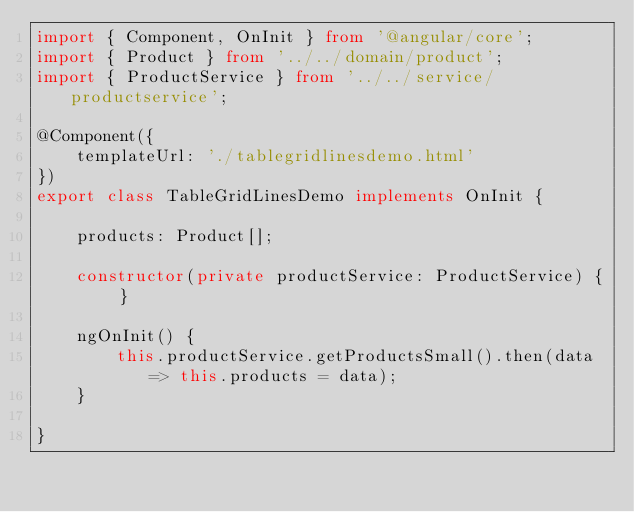Convert code to text. <code><loc_0><loc_0><loc_500><loc_500><_TypeScript_>import { Component, OnInit } from '@angular/core';
import { Product } from '../../domain/product';
import { ProductService } from '../../service/productservice';

@Component({
    templateUrl: './tablegridlinesdemo.html'
})
export class TableGridLinesDemo implements OnInit {

    products: Product[];

    constructor(private productService: ProductService) { }

    ngOnInit() {
        this.productService.getProductsSmall().then(data => this.products = data);
    }
    
}</code> 